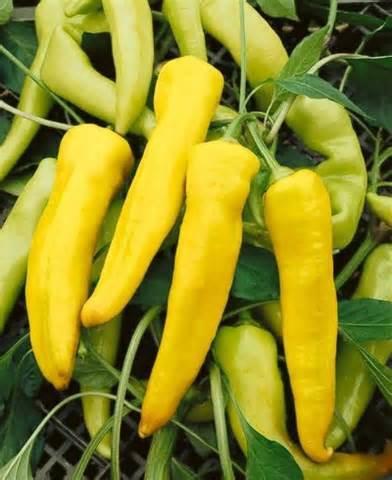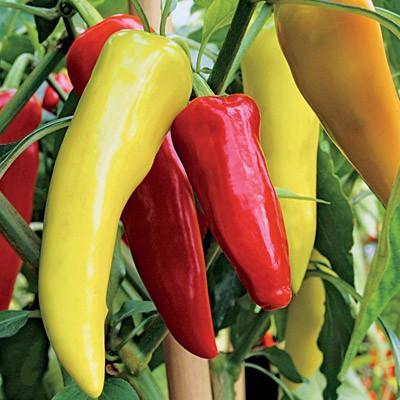The first image is the image on the left, the second image is the image on the right. Given the left and right images, does the statement "Both images in the pair show hot peppers that are yellow, orange, red, and green." hold true? Answer yes or no. No. 